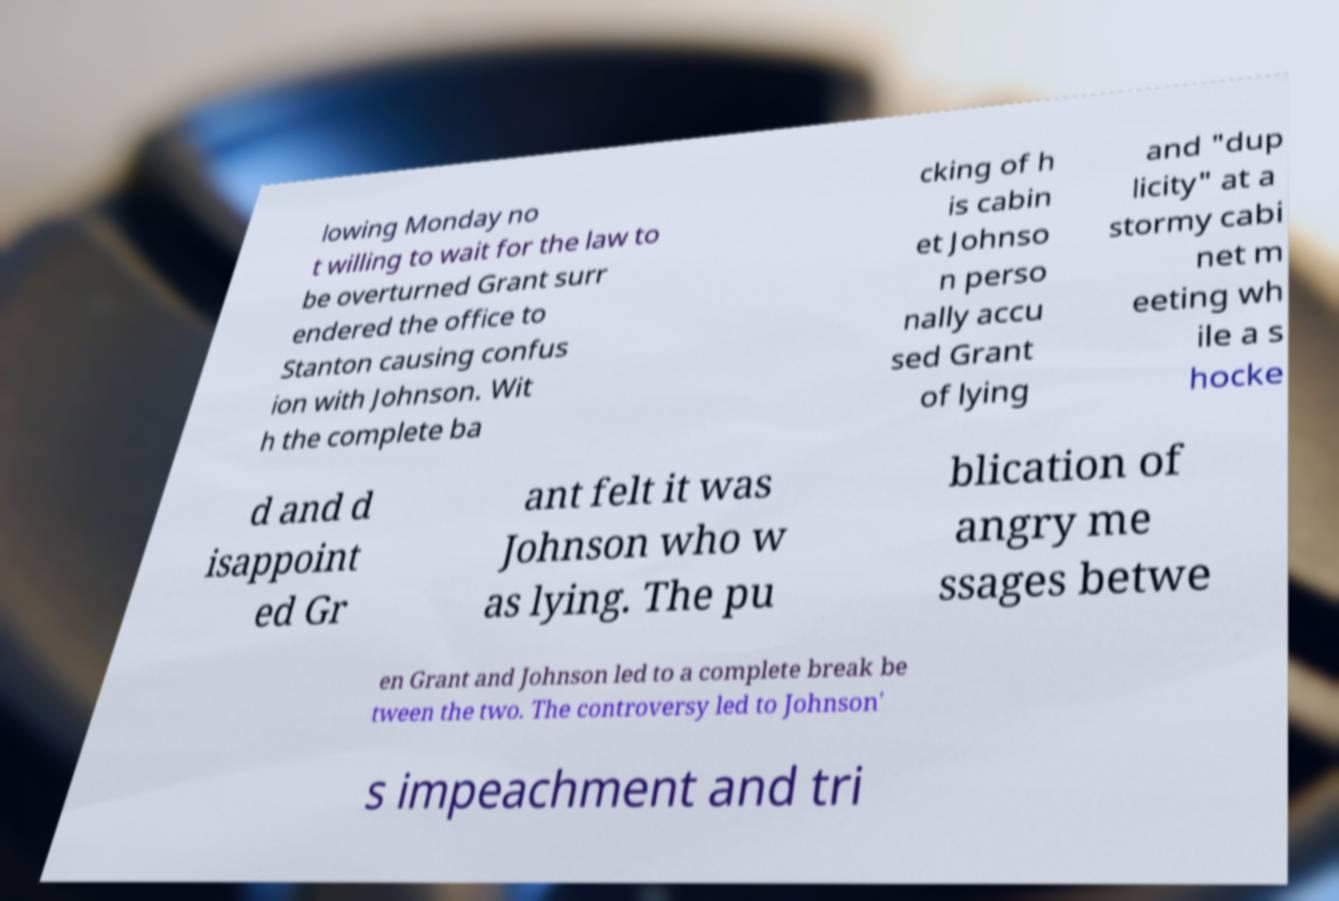Can you read and provide the text displayed in the image?This photo seems to have some interesting text. Can you extract and type it out for me? lowing Monday no t willing to wait for the law to be overturned Grant surr endered the office to Stanton causing confus ion with Johnson. Wit h the complete ba cking of h is cabin et Johnso n perso nally accu sed Grant of lying and "dup licity" at a stormy cabi net m eeting wh ile a s hocke d and d isappoint ed Gr ant felt it was Johnson who w as lying. The pu blication of angry me ssages betwe en Grant and Johnson led to a complete break be tween the two. The controversy led to Johnson' s impeachment and tri 